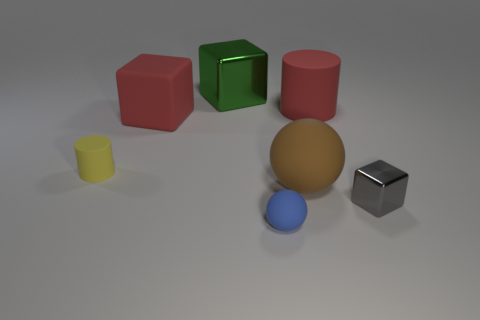The shiny object that is the same size as the yellow matte thing is what color?
Your answer should be compact. Gray. Is the number of blue rubber spheres that are behind the tiny yellow cylinder greater than the number of small brown shiny things?
Your answer should be compact. No. What is the material of the big thing that is right of the small blue matte ball and behind the small cylinder?
Offer a terse response. Rubber. There is a small object that is behind the tiny gray metallic object; is its color the same as the small matte object on the right side of the rubber cube?
Your answer should be compact. No. What number of other objects are there of the same size as the red cylinder?
Make the answer very short. 3. Are there any yellow rubber objects that are right of the small rubber thing behind the metallic cube in front of the small yellow cylinder?
Your answer should be very brief. No. Does the ball that is in front of the tiny gray thing have the same material as the large sphere?
Provide a short and direct response. Yes. There is a matte thing that is the same shape as the tiny gray metal object; what is its color?
Keep it short and to the point. Red. Is there anything else that is the same shape as the brown thing?
Provide a short and direct response. Yes. Are there the same number of green metal cubes behind the large green shiny cube and green shiny things?
Your answer should be compact. No. 